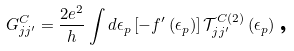Convert formula to latex. <formula><loc_0><loc_0><loc_500><loc_500>G _ { j j ^ { \prime } } ^ { C } = \frac { 2 e ^ { 2 } } { h } \int d \epsilon _ { p } \left [ - f ^ { \prime } \left ( \epsilon _ { p } \right ) \right ] \mathcal { T } _ { j j ^ { \prime } } ^ { C \left ( 2 \right ) } \left ( \epsilon _ { p } \right ) \text {,}</formula> 